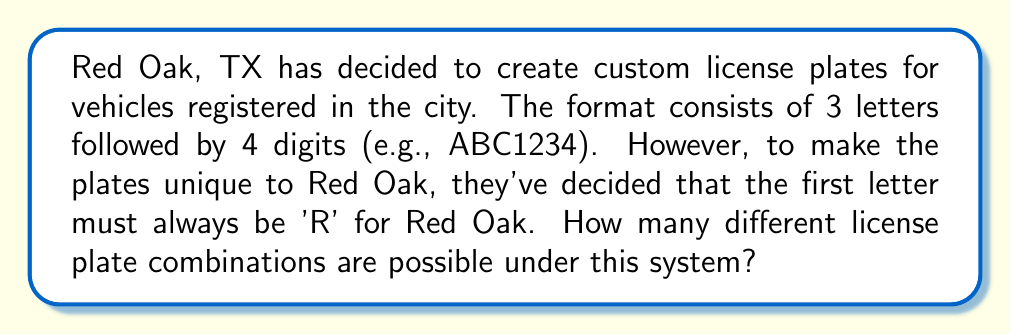Give your solution to this math problem. Let's break this down step-by-step:

1) The first letter is always 'R', so there's only 1 choice for this position.

2) For the second letter, we can use any of the 26 letters in the alphabet. So there are 26 choices.

3) The same applies to the third letter - 26 choices.

4) For each of the 4 digit positions, we can use any digit from 0 to 9. So there are 10 choices for each digit position.

5) Using the multiplication principle of counting, we multiply the number of choices for each position:

   $$ 1 \times 26 \times 26 \times 10 \times 10 \times 10 \times 10 $$

6) This simplifies to:

   $$ 1 \times 26^2 \times 10^4 $$

7) Calculating this:
   
   $$ 1 \times 676 \times 10,000 = 6,760,000 $$

Therefore, there are 6,760,000 possible license plate combinations for vehicles registered in Red Oak, TX under this system.
Answer: 6,760,000 